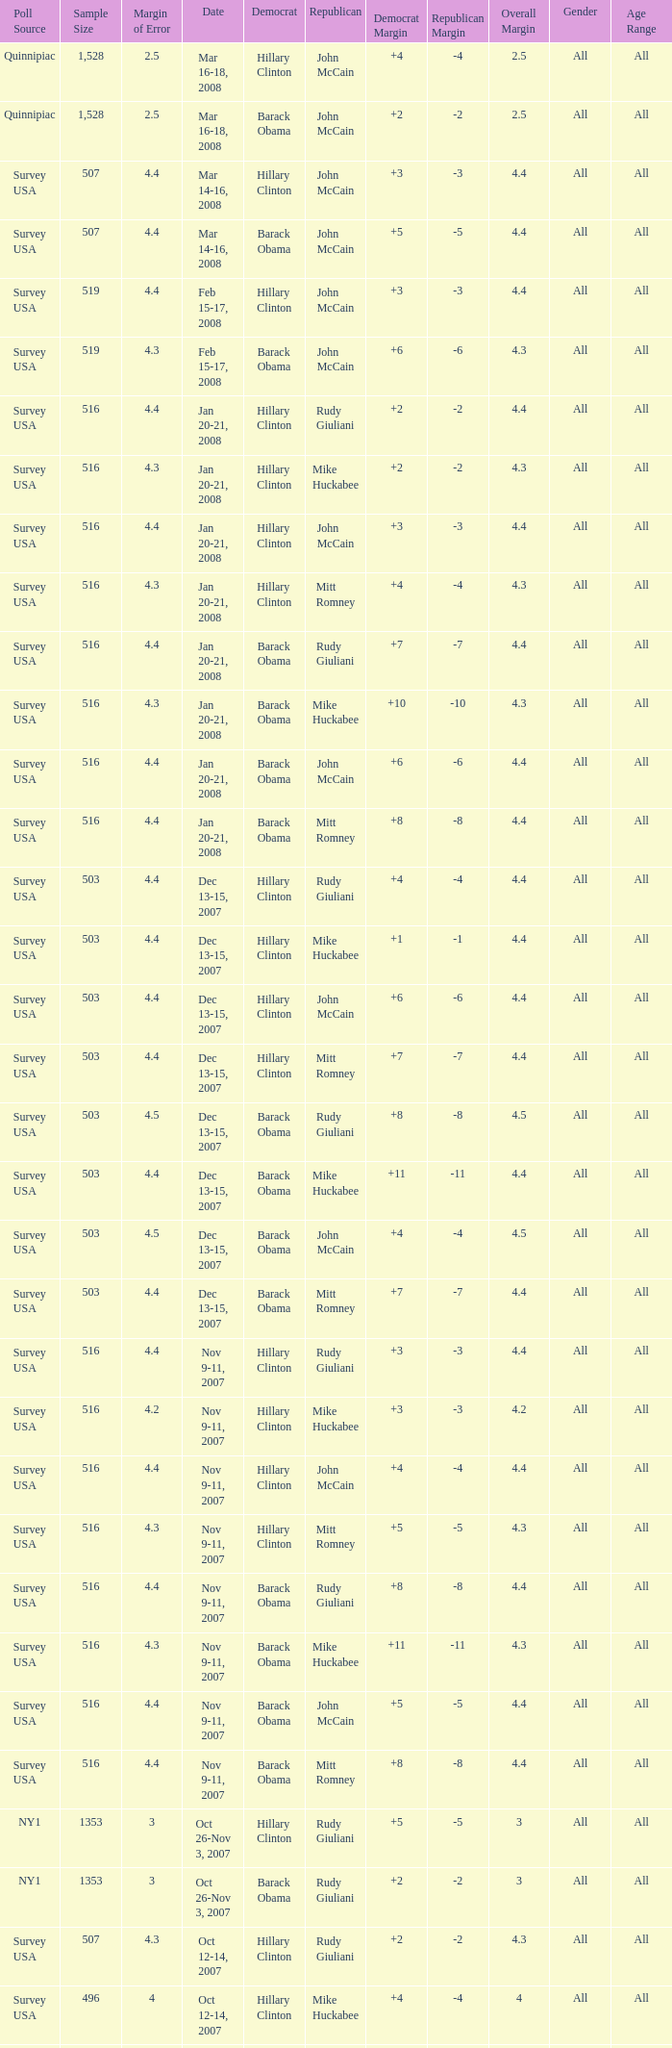What was the date of the poll with a sample size of 496 where Republican Mike Huckabee was chosen? Oct 12-14, 2007. 